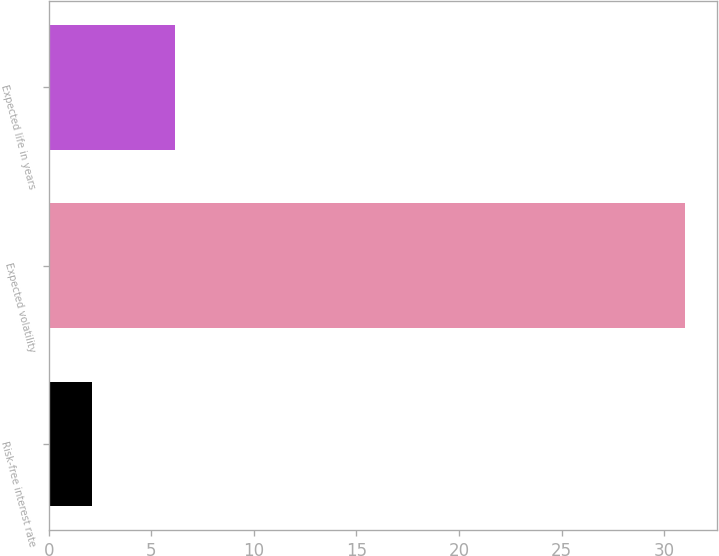<chart> <loc_0><loc_0><loc_500><loc_500><bar_chart><fcel>Risk-free interest rate<fcel>Expected volatility<fcel>Expected life in years<nl><fcel>2.13<fcel>31<fcel>6.17<nl></chart> 